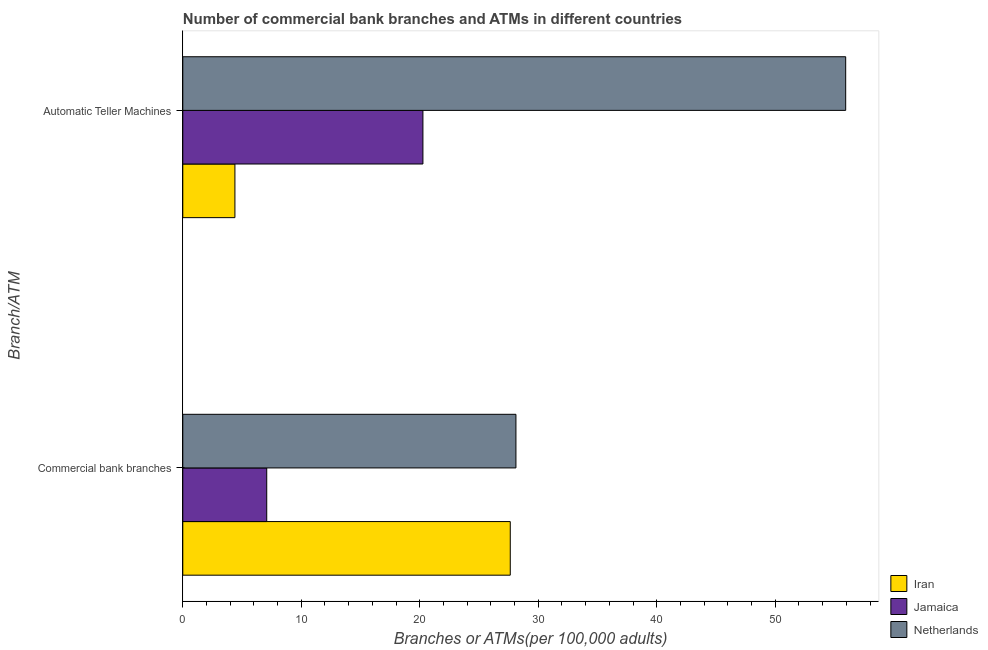How many different coloured bars are there?
Keep it short and to the point. 3. How many groups of bars are there?
Offer a terse response. 2. Are the number of bars per tick equal to the number of legend labels?
Ensure brevity in your answer.  Yes. Are the number of bars on each tick of the Y-axis equal?
Make the answer very short. Yes. How many bars are there on the 1st tick from the top?
Offer a very short reply. 3. What is the label of the 2nd group of bars from the top?
Provide a short and direct response. Commercial bank branches. What is the number of atms in Jamaica?
Make the answer very short. 20.26. Across all countries, what is the maximum number of atms?
Offer a very short reply. 55.94. Across all countries, what is the minimum number of atms?
Offer a very short reply. 4.4. In which country was the number of atms maximum?
Ensure brevity in your answer.  Netherlands. In which country was the number of commercal bank branches minimum?
Provide a succinct answer. Jamaica. What is the total number of atms in the graph?
Ensure brevity in your answer.  80.61. What is the difference between the number of commercal bank branches in Jamaica and that in Netherlands?
Your answer should be very brief. -21.03. What is the difference between the number of commercal bank branches in Iran and the number of atms in Netherlands?
Give a very brief answer. -28.31. What is the average number of commercal bank branches per country?
Your answer should be very brief. 20.95. What is the difference between the number of atms and number of commercal bank branches in Jamaica?
Give a very brief answer. 13.18. In how many countries, is the number of commercal bank branches greater than 34 ?
Make the answer very short. 0. What is the ratio of the number of commercal bank branches in Iran to that in Jamaica?
Provide a short and direct response. 3.9. In how many countries, is the number of commercal bank branches greater than the average number of commercal bank branches taken over all countries?
Provide a short and direct response. 2. What does the 3rd bar from the top in Commercial bank branches represents?
Give a very brief answer. Iran. What does the 2nd bar from the bottom in Commercial bank branches represents?
Give a very brief answer. Jamaica. Are all the bars in the graph horizontal?
Your response must be concise. Yes. What is the difference between two consecutive major ticks on the X-axis?
Provide a short and direct response. 10. Are the values on the major ticks of X-axis written in scientific E-notation?
Make the answer very short. No. How many legend labels are there?
Give a very brief answer. 3. What is the title of the graph?
Ensure brevity in your answer.  Number of commercial bank branches and ATMs in different countries. Does "Sierra Leone" appear as one of the legend labels in the graph?
Provide a short and direct response. No. What is the label or title of the X-axis?
Your answer should be very brief. Branches or ATMs(per 100,0 adults). What is the label or title of the Y-axis?
Give a very brief answer. Branch/ATM. What is the Branches or ATMs(per 100,000 adults) in Iran in Commercial bank branches?
Give a very brief answer. 27.64. What is the Branches or ATMs(per 100,000 adults) of Jamaica in Commercial bank branches?
Keep it short and to the point. 7.08. What is the Branches or ATMs(per 100,000 adults) of Netherlands in Commercial bank branches?
Give a very brief answer. 28.11. What is the Branches or ATMs(per 100,000 adults) of Iran in Automatic Teller Machines?
Provide a short and direct response. 4.4. What is the Branches or ATMs(per 100,000 adults) in Jamaica in Automatic Teller Machines?
Offer a terse response. 20.26. What is the Branches or ATMs(per 100,000 adults) of Netherlands in Automatic Teller Machines?
Offer a very short reply. 55.94. Across all Branch/ATM, what is the maximum Branches or ATMs(per 100,000 adults) in Iran?
Ensure brevity in your answer.  27.64. Across all Branch/ATM, what is the maximum Branches or ATMs(per 100,000 adults) in Jamaica?
Your answer should be compact. 20.26. Across all Branch/ATM, what is the maximum Branches or ATMs(per 100,000 adults) of Netherlands?
Offer a very short reply. 55.94. Across all Branch/ATM, what is the minimum Branches or ATMs(per 100,000 adults) of Iran?
Your answer should be very brief. 4.4. Across all Branch/ATM, what is the minimum Branches or ATMs(per 100,000 adults) in Jamaica?
Offer a very short reply. 7.08. Across all Branch/ATM, what is the minimum Branches or ATMs(per 100,000 adults) of Netherlands?
Give a very brief answer. 28.11. What is the total Branches or ATMs(per 100,000 adults) of Iran in the graph?
Offer a very short reply. 32.03. What is the total Branches or ATMs(per 100,000 adults) of Jamaica in the graph?
Offer a very short reply. 27.35. What is the total Branches or ATMs(per 100,000 adults) of Netherlands in the graph?
Provide a short and direct response. 84.06. What is the difference between the Branches or ATMs(per 100,000 adults) of Iran in Commercial bank branches and that in Automatic Teller Machines?
Make the answer very short. 23.24. What is the difference between the Branches or ATMs(per 100,000 adults) in Jamaica in Commercial bank branches and that in Automatic Teller Machines?
Your response must be concise. -13.18. What is the difference between the Branches or ATMs(per 100,000 adults) in Netherlands in Commercial bank branches and that in Automatic Teller Machines?
Provide a succinct answer. -27.83. What is the difference between the Branches or ATMs(per 100,000 adults) of Iran in Commercial bank branches and the Branches or ATMs(per 100,000 adults) of Jamaica in Automatic Teller Machines?
Provide a short and direct response. 7.37. What is the difference between the Branches or ATMs(per 100,000 adults) of Iran in Commercial bank branches and the Branches or ATMs(per 100,000 adults) of Netherlands in Automatic Teller Machines?
Give a very brief answer. -28.31. What is the difference between the Branches or ATMs(per 100,000 adults) of Jamaica in Commercial bank branches and the Branches or ATMs(per 100,000 adults) of Netherlands in Automatic Teller Machines?
Keep it short and to the point. -48.86. What is the average Branches or ATMs(per 100,000 adults) of Iran per Branch/ATM?
Ensure brevity in your answer.  16.02. What is the average Branches or ATMs(per 100,000 adults) in Jamaica per Branch/ATM?
Your response must be concise. 13.67. What is the average Branches or ATMs(per 100,000 adults) in Netherlands per Branch/ATM?
Your answer should be very brief. 42.03. What is the difference between the Branches or ATMs(per 100,000 adults) of Iran and Branches or ATMs(per 100,000 adults) of Jamaica in Commercial bank branches?
Your answer should be compact. 20.55. What is the difference between the Branches or ATMs(per 100,000 adults) in Iran and Branches or ATMs(per 100,000 adults) in Netherlands in Commercial bank branches?
Make the answer very short. -0.48. What is the difference between the Branches or ATMs(per 100,000 adults) in Jamaica and Branches or ATMs(per 100,000 adults) in Netherlands in Commercial bank branches?
Your answer should be very brief. -21.03. What is the difference between the Branches or ATMs(per 100,000 adults) of Iran and Branches or ATMs(per 100,000 adults) of Jamaica in Automatic Teller Machines?
Your answer should be very brief. -15.87. What is the difference between the Branches or ATMs(per 100,000 adults) of Iran and Branches or ATMs(per 100,000 adults) of Netherlands in Automatic Teller Machines?
Offer a very short reply. -51.55. What is the difference between the Branches or ATMs(per 100,000 adults) in Jamaica and Branches or ATMs(per 100,000 adults) in Netherlands in Automatic Teller Machines?
Offer a terse response. -35.68. What is the ratio of the Branches or ATMs(per 100,000 adults) in Iran in Commercial bank branches to that in Automatic Teller Machines?
Provide a short and direct response. 6.28. What is the ratio of the Branches or ATMs(per 100,000 adults) in Jamaica in Commercial bank branches to that in Automatic Teller Machines?
Make the answer very short. 0.35. What is the ratio of the Branches or ATMs(per 100,000 adults) in Netherlands in Commercial bank branches to that in Automatic Teller Machines?
Your answer should be very brief. 0.5. What is the difference between the highest and the second highest Branches or ATMs(per 100,000 adults) of Iran?
Give a very brief answer. 23.24. What is the difference between the highest and the second highest Branches or ATMs(per 100,000 adults) of Jamaica?
Offer a very short reply. 13.18. What is the difference between the highest and the second highest Branches or ATMs(per 100,000 adults) of Netherlands?
Keep it short and to the point. 27.83. What is the difference between the highest and the lowest Branches or ATMs(per 100,000 adults) of Iran?
Your answer should be very brief. 23.24. What is the difference between the highest and the lowest Branches or ATMs(per 100,000 adults) of Jamaica?
Give a very brief answer. 13.18. What is the difference between the highest and the lowest Branches or ATMs(per 100,000 adults) of Netherlands?
Keep it short and to the point. 27.83. 